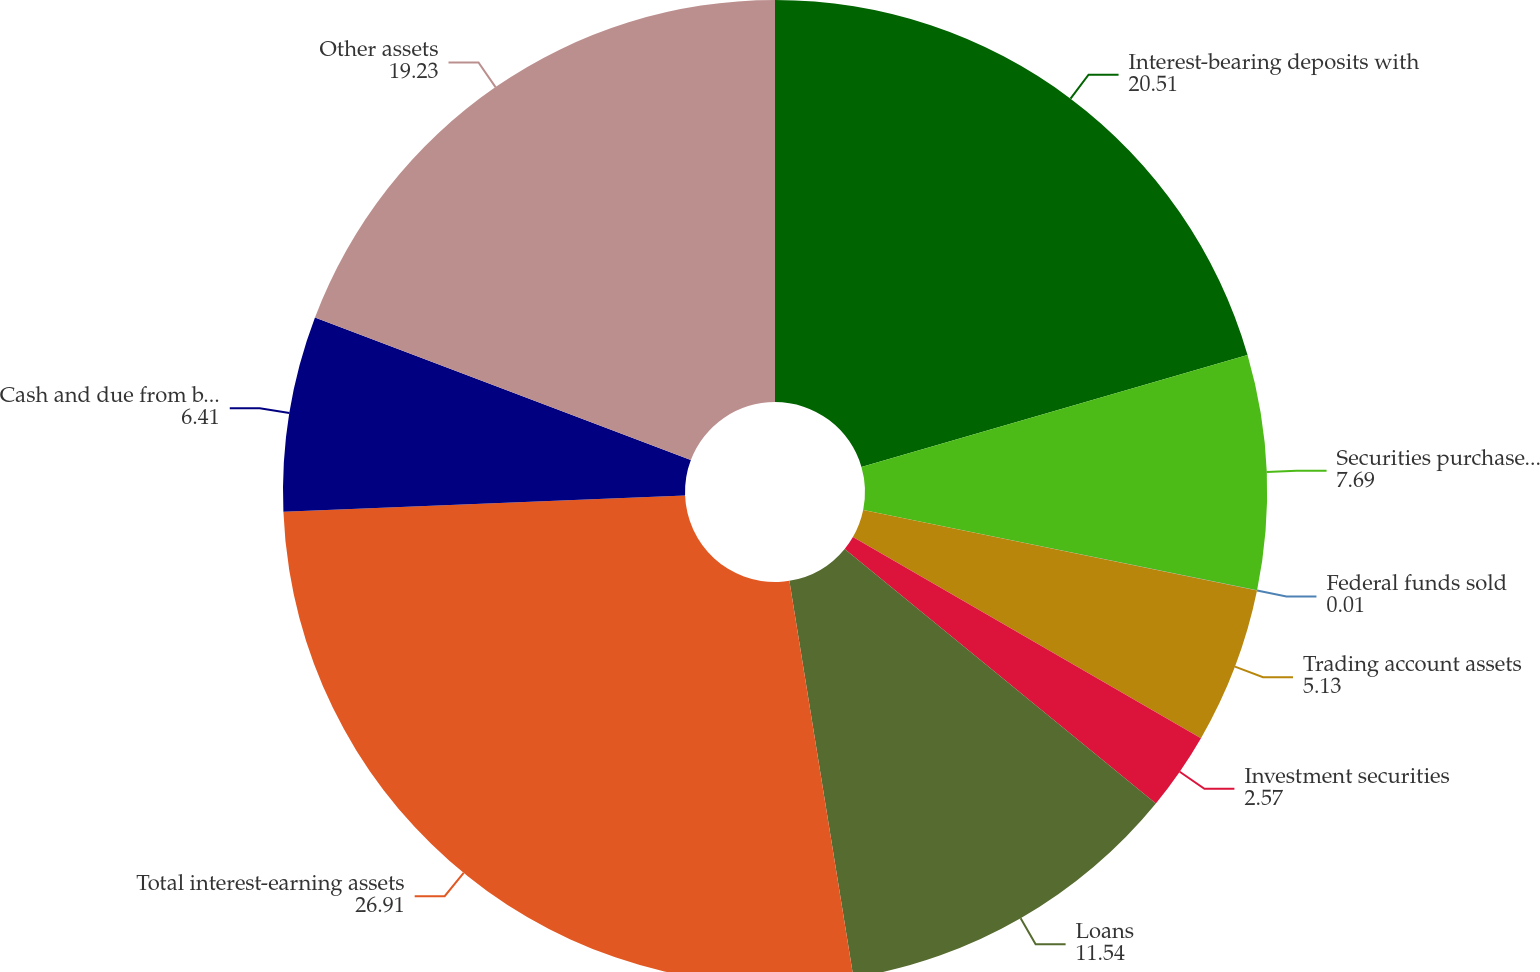<chart> <loc_0><loc_0><loc_500><loc_500><pie_chart><fcel>Interest-bearing deposits with<fcel>Securities purchased under<fcel>Federal funds sold<fcel>Trading account assets<fcel>Investment securities<fcel>Loans<fcel>Total interest-earning assets<fcel>Cash and due from banks<fcel>Other assets<nl><fcel>20.51%<fcel>7.69%<fcel>0.01%<fcel>5.13%<fcel>2.57%<fcel>11.54%<fcel>26.91%<fcel>6.41%<fcel>19.23%<nl></chart> 